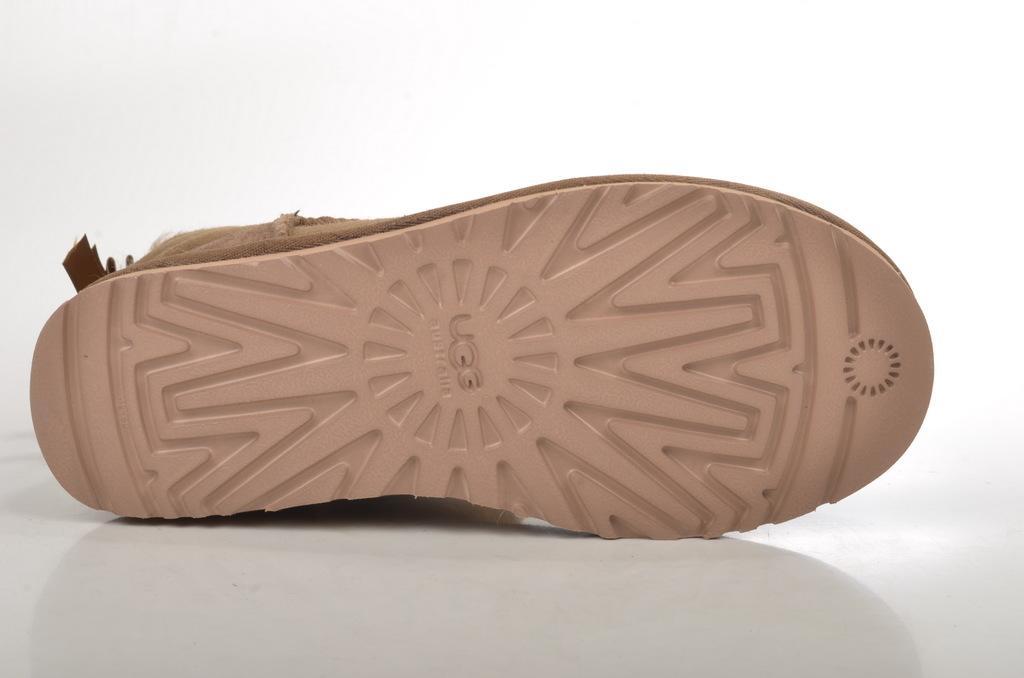Describe this image in one or two sentences. In this image we can see a shoe on the white surface. In the background we can see the plain wall. 